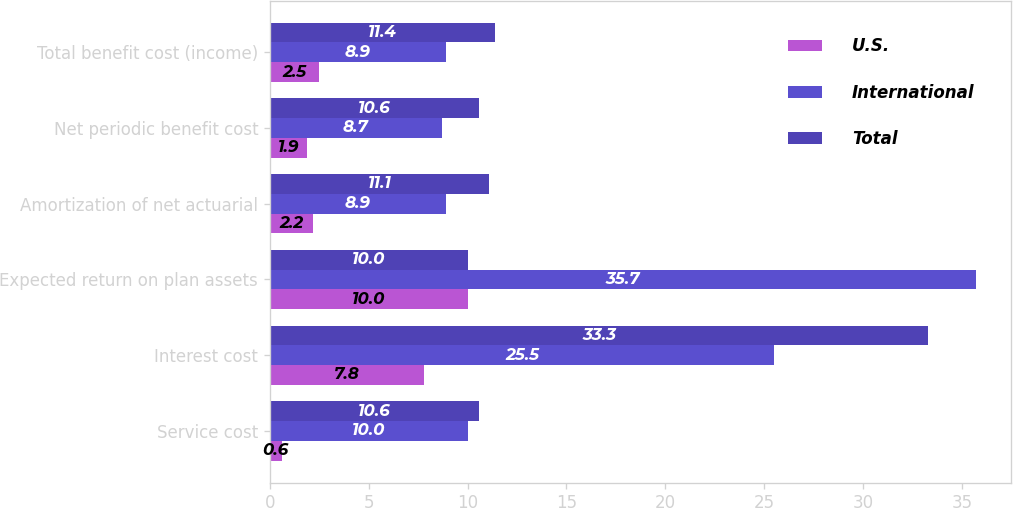Convert chart. <chart><loc_0><loc_0><loc_500><loc_500><stacked_bar_chart><ecel><fcel>Service cost<fcel>Interest cost<fcel>Expected return on plan assets<fcel>Amortization of net actuarial<fcel>Net periodic benefit cost<fcel>Total benefit cost (income)<nl><fcel>U.S.<fcel>0.6<fcel>7.8<fcel>10<fcel>2.2<fcel>1.9<fcel>2.5<nl><fcel>International<fcel>10<fcel>25.5<fcel>35.7<fcel>8.9<fcel>8.7<fcel>8.9<nl><fcel>Total<fcel>10.6<fcel>33.3<fcel>10<fcel>11.1<fcel>10.6<fcel>11.4<nl></chart> 